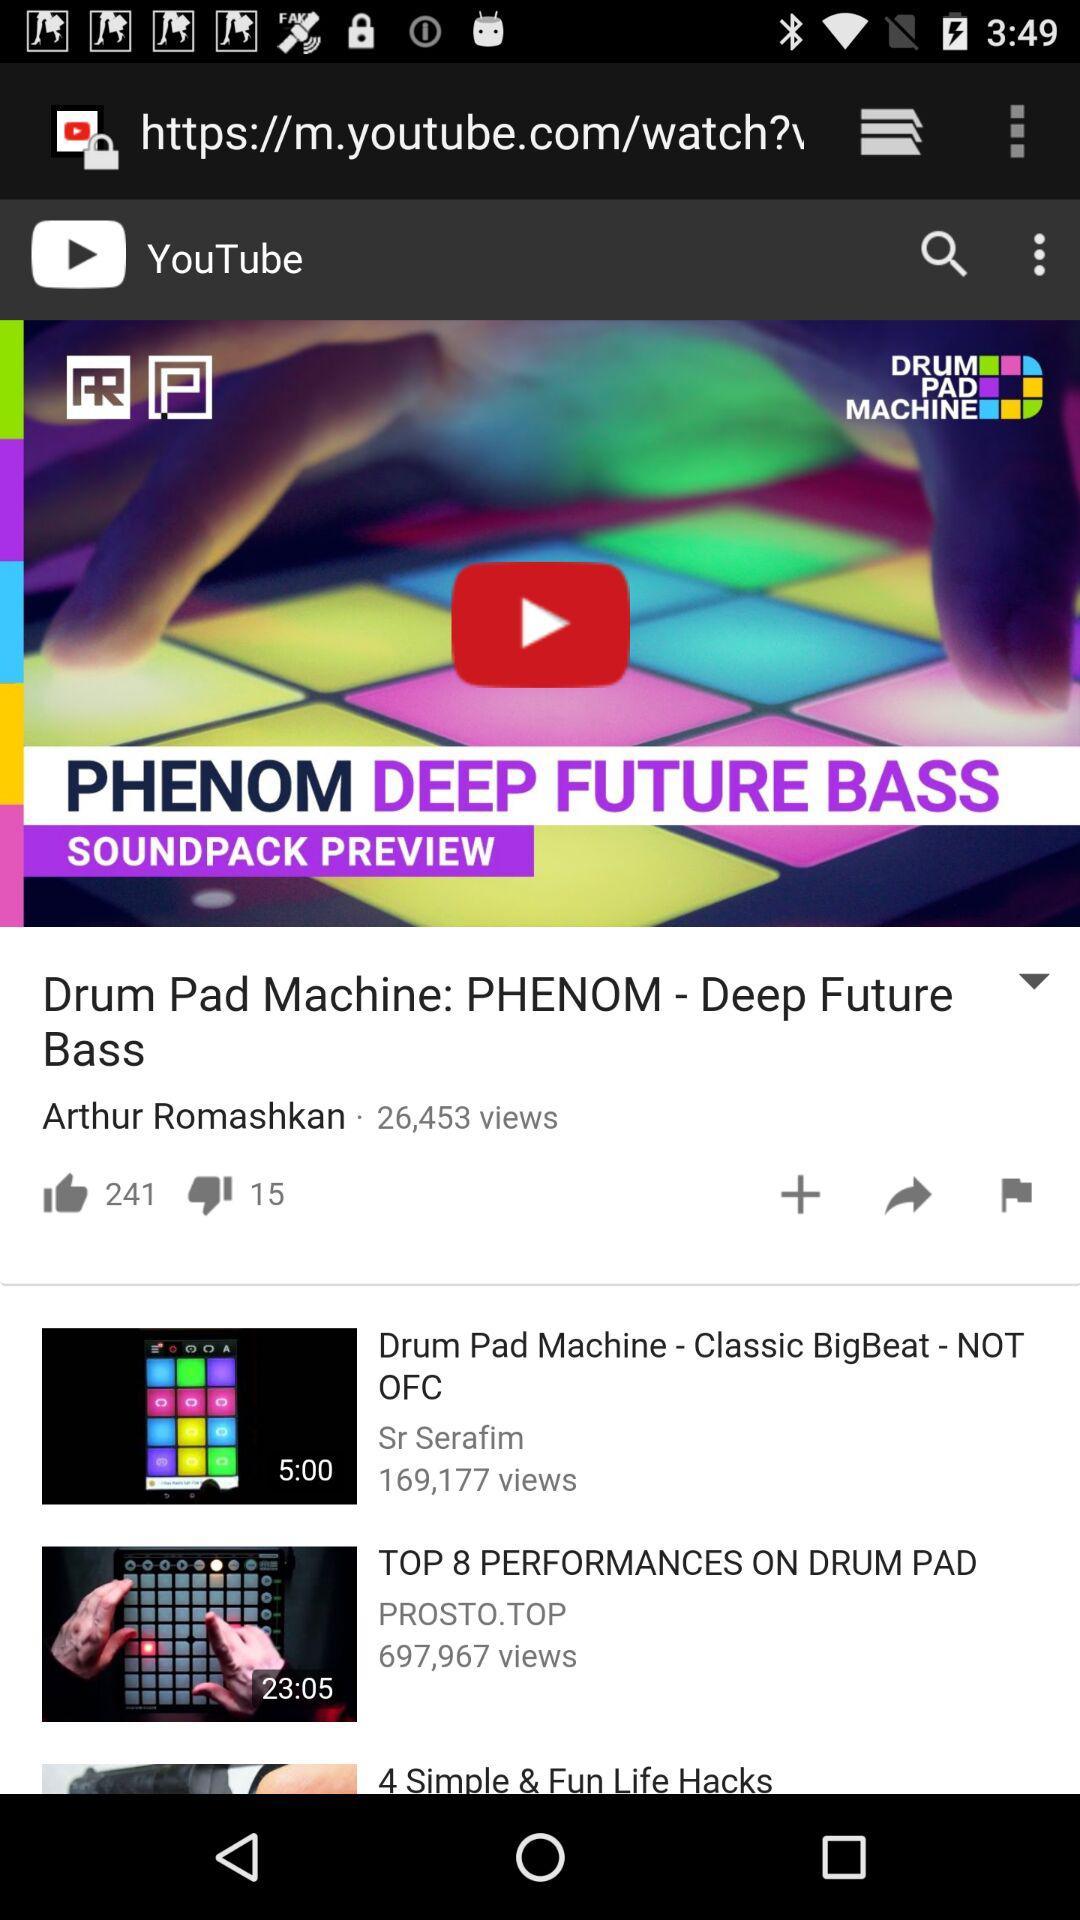How many views are shown on the video "Drum Pad Machine: PHENOM - Deep Future Bass"? There are 26,453 views. 